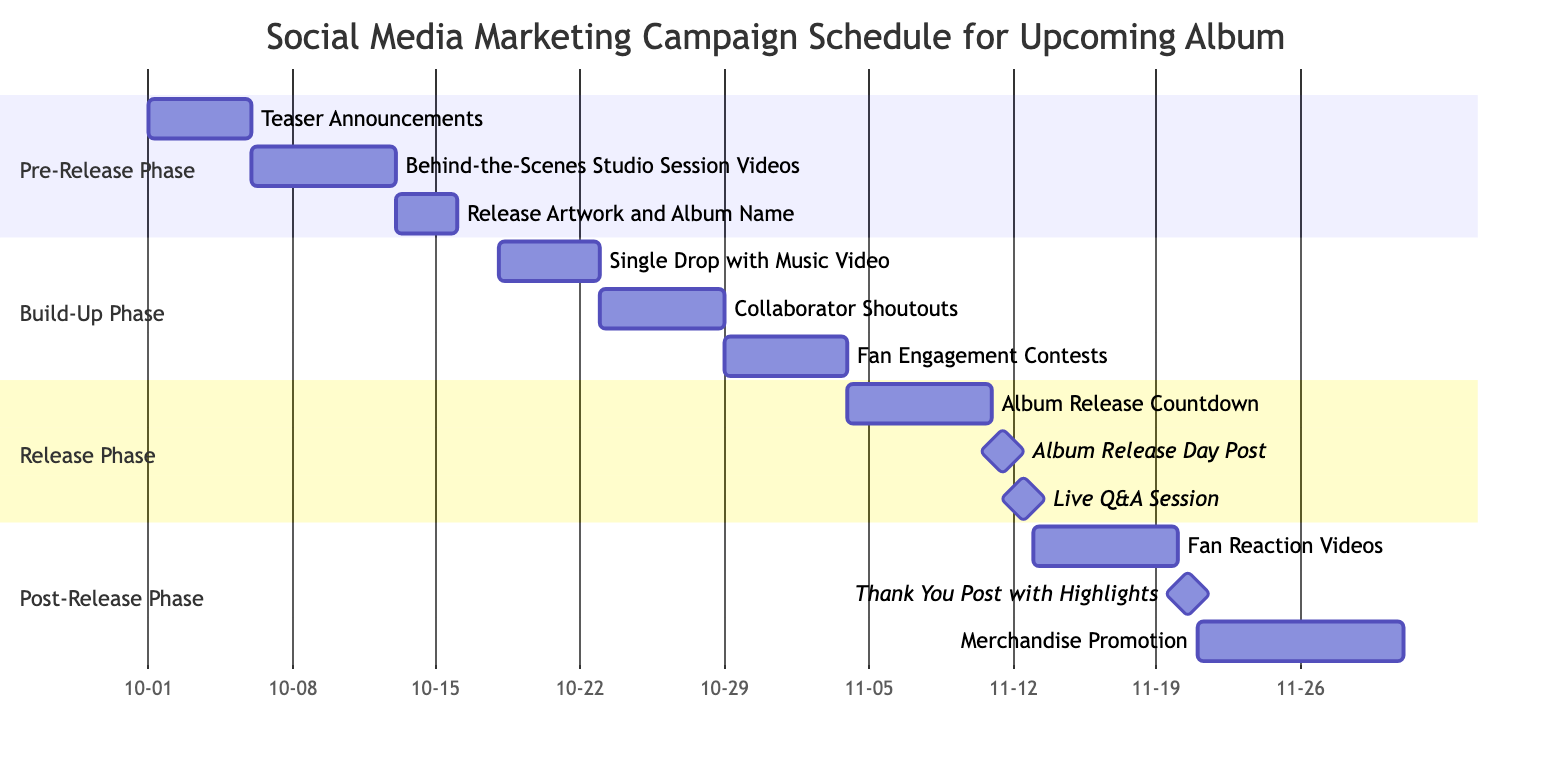what is the duration of the "Teaser Announcements" task? The "Teaser Announcements" task starts on October 1, 2023, and ends on October 5, 2023. Therefore, the duration can be calculated as the difference between the end and start dates, which is 5 days.
Answer: 5 days how many tasks are in the "Build-Up Phase"? The "Build-Up Phase" contains three tasks: "Single Drop with Music Video," "Collaborator Shoutouts," and "Fan Engagement Contests." By simply counting the tasks listed in that phase, we find that there are three.
Answer: 3 when does the "Album Release Countdown" start? The "Album Release Countdown" task starts on November 4, 2023. This date is explicitly indicated as the start date for this specific task.
Answer: November 4 what is the latest task in the "Post-Release Phase"? The latest task in the "Post-Release Phase" is "Merchandise Promotion," which ends on November 30, 2023. By examining the end dates of tasks in this phase, we see that "Merchandise Promotion" has the latest end date.
Answer: Merchandise Promotion which phase includes the "Live Q&A Session"? The "Live Q&A Session" is featured in the "Release Phase." By locating the task in the diagram, we can see it falls under the designated section for the "Release Phase."
Answer: Release Phase how many days are between "Single Drop with Music Video" and "Collaborator Shoutouts" task? The "Single Drop with Music Video" ends on October 22, 2023, and "Collaborator Shoutouts" starts on October 23, 2023. The gap between these two tasks is 1 day, calculated by subtracting the start date of the latter from the end date of the former.
Answer: 1 day what milestones are included in the "Release Phase"? The milestones in the "Release Phase" are "Album Release Day Post" and "Live Q&A Session." Milestones are specifically marked as single-day tasks; thus, by identifying these markers in the phase, we can conclude that these are the two milestones.
Answer: Album Release Day Post, Live Q&A Session which task has the shortest duration in the entire campaign? The task with the shortest duration is the "Album Release Day Post," which occurs on November 11, 2023, for just one day. By checking the durations of all tasks, it is clear that this is the only task that lasts a single day.
Answer: Album Release Day Post 